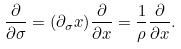<formula> <loc_0><loc_0><loc_500><loc_500>\frac { \partial } { \partial \sigma } = ( \partial _ { \sigma } x ) \frac { \partial } { \partial x } = \frac { 1 } { \rho } \frac { \partial } { \partial x } .</formula> 